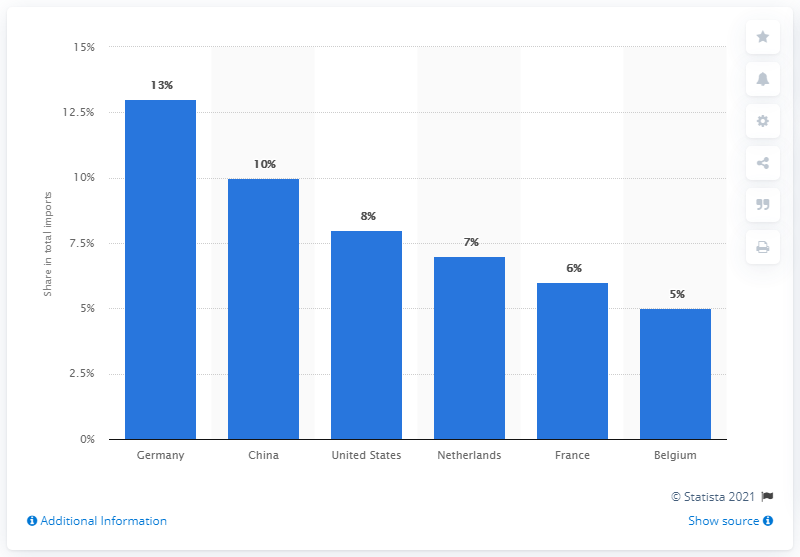Identify some key points in this picture. In 2019, Germany's share of total imports was approximately 13%. In 2019, Germany was the main import partner for the United Kingdom. 